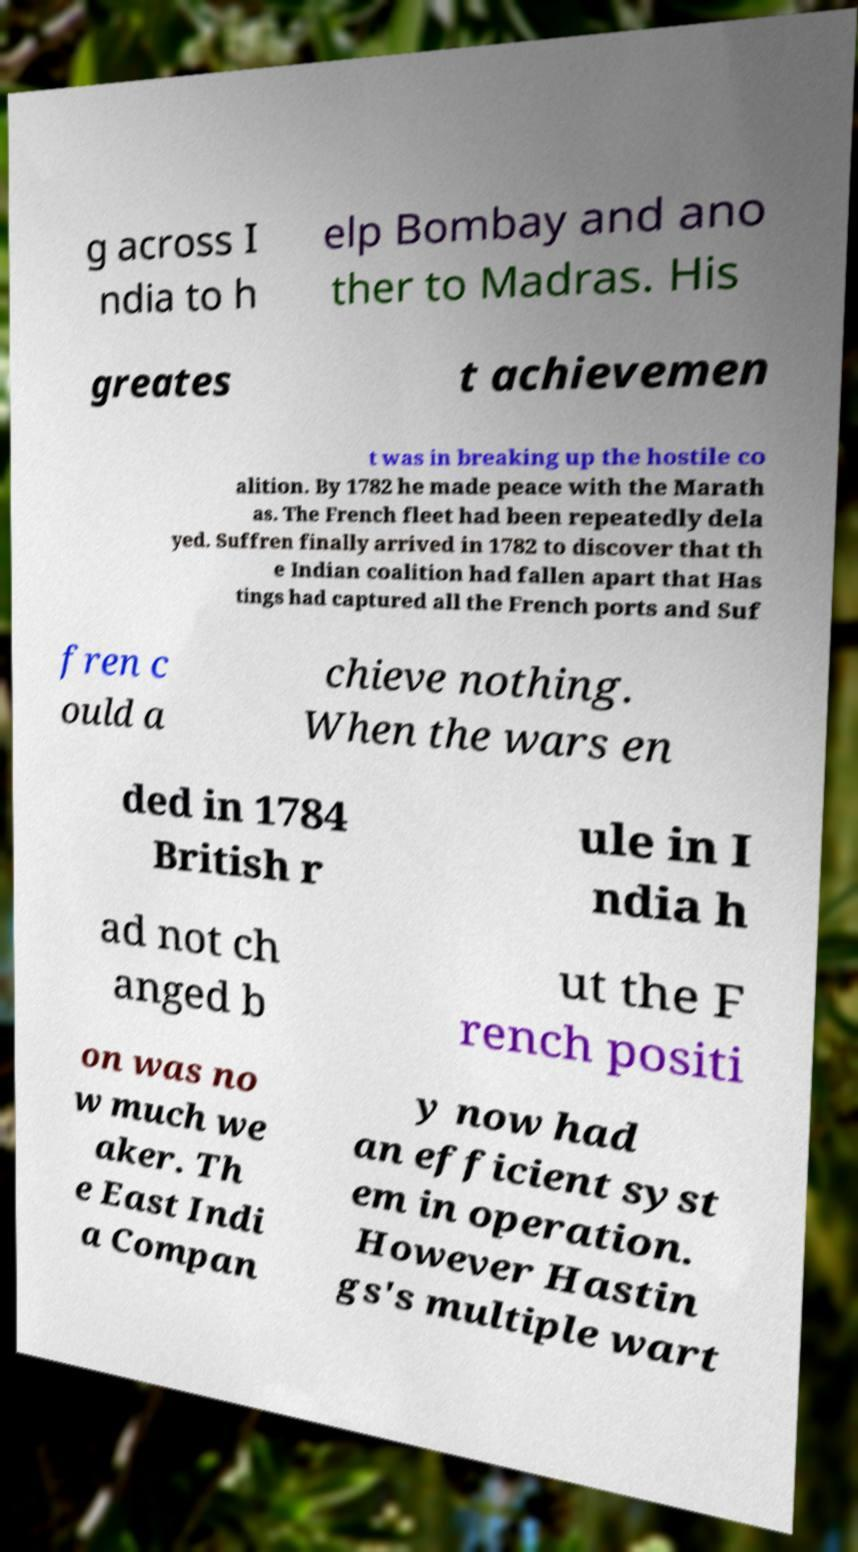For documentation purposes, I need the text within this image transcribed. Could you provide that? g across I ndia to h elp Bombay and ano ther to Madras. His greates t achievemen t was in breaking up the hostile co alition. By 1782 he made peace with the Marath as. The French fleet had been repeatedly dela yed. Suffren finally arrived in 1782 to discover that th e Indian coalition had fallen apart that Has tings had captured all the French ports and Suf fren c ould a chieve nothing. When the wars en ded in 1784 British r ule in I ndia h ad not ch anged b ut the F rench positi on was no w much we aker. Th e East Indi a Compan y now had an efficient syst em in operation. However Hastin gs's multiple wart 